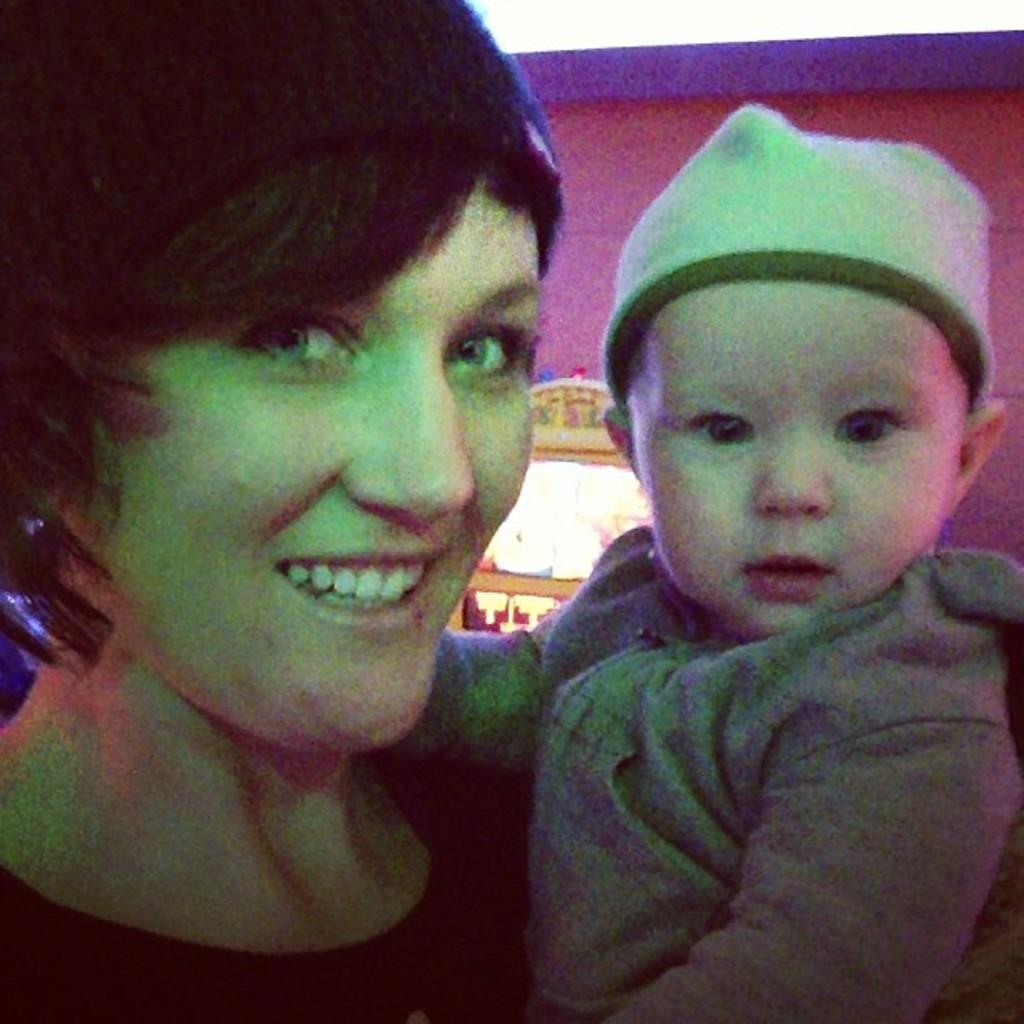Who is the main subject in the image? There is a woman in the image. What is the woman doing in the image? The woman is holding a baby. What can be seen in the background of the image? There is a wall in the image. What is located behind the woman? There is an object behind the woman. Can you see the woman breaking a record in the image? There is no record-breaking activity depicted in the image. Is the woman kissing the baby in the image? The image does not show the woman kissing the baby, only holding it. 